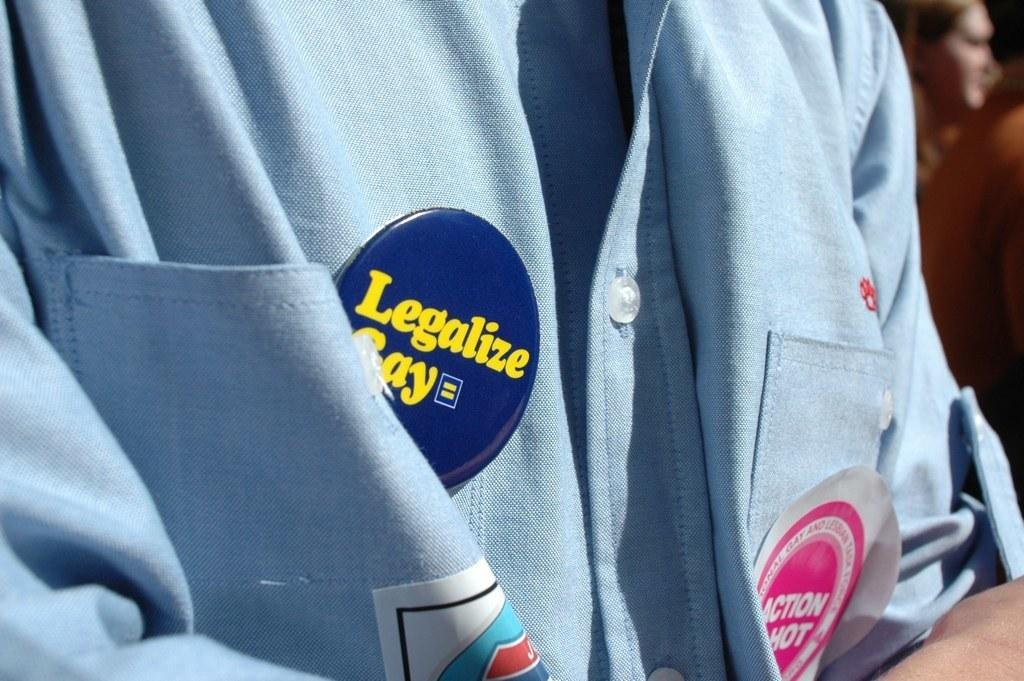<image>
Provide a brief description of the given image. A button on a shirt says to legalize along with a sticker that says Action Hot. 